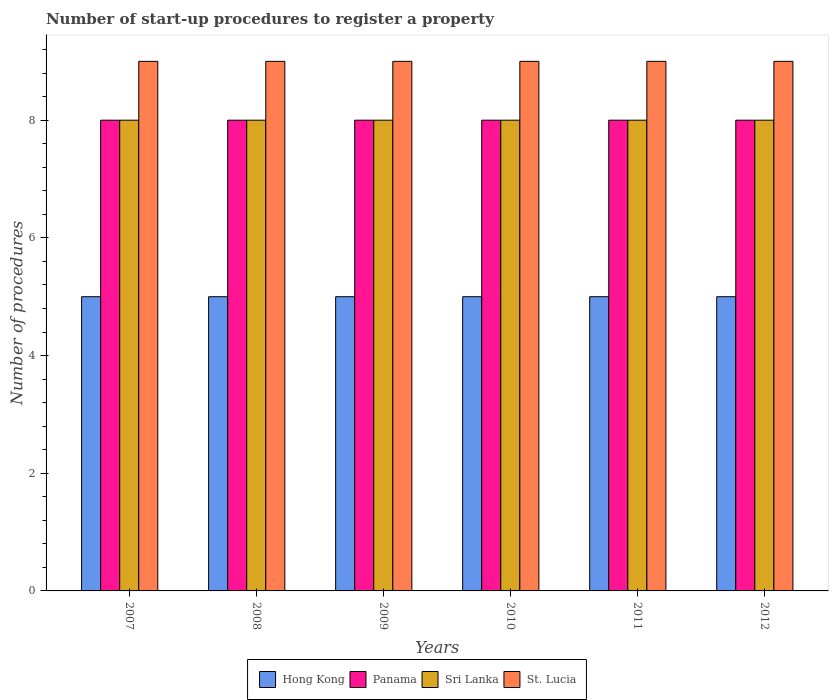How many groups of bars are there?
Your answer should be very brief. 6. Are the number of bars per tick equal to the number of legend labels?
Offer a terse response. Yes. Are the number of bars on each tick of the X-axis equal?
Your answer should be very brief. Yes. How many bars are there on the 2nd tick from the right?
Give a very brief answer. 4. What is the label of the 4th group of bars from the left?
Ensure brevity in your answer.  2010. What is the number of procedures required to register a property in Hong Kong in 2010?
Your response must be concise. 5. Across all years, what is the maximum number of procedures required to register a property in Panama?
Your answer should be compact. 8. Across all years, what is the minimum number of procedures required to register a property in Panama?
Give a very brief answer. 8. In which year was the number of procedures required to register a property in Sri Lanka minimum?
Your answer should be very brief. 2007. What is the total number of procedures required to register a property in Panama in the graph?
Provide a short and direct response. 48. What is the difference between the number of procedures required to register a property in Hong Kong in 2009 and that in 2011?
Your answer should be compact. 0. What is the difference between the number of procedures required to register a property in Hong Kong in 2007 and the number of procedures required to register a property in Sri Lanka in 2012?
Give a very brief answer. -3. What is the average number of procedures required to register a property in Panama per year?
Make the answer very short. 8. In the year 2010, what is the difference between the number of procedures required to register a property in Sri Lanka and number of procedures required to register a property in Hong Kong?
Ensure brevity in your answer.  3. What is the ratio of the number of procedures required to register a property in Sri Lanka in 2008 to that in 2012?
Ensure brevity in your answer.  1. Is the number of procedures required to register a property in Panama in 2007 less than that in 2009?
Your answer should be very brief. No. Is the difference between the number of procedures required to register a property in Sri Lanka in 2008 and 2011 greater than the difference between the number of procedures required to register a property in Hong Kong in 2008 and 2011?
Your answer should be very brief. No. What is the difference between the highest and the lowest number of procedures required to register a property in Sri Lanka?
Provide a short and direct response. 0. Is it the case that in every year, the sum of the number of procedures required to register a property in St. Lucia and number of procedures required to register a property in Hong Kong is greater than the sum of number of procedures required to register a property in Panama and number of procedures required to register a property in Sri Lanka?
Provide a short and direct response. Yes. What does the 2nd bar from the left in 2007 represents?
Offer a very short reply. Panama. What does the 3rd bar from the right in 2007 represents?
Provide a succinct answer. Panama. Are the values on the major ticks of Y-axis written in scientific E-notation?
Keep it short and to the point. No. Does the graph contain any zero values?
Offer a very short reply. No. Does the graph contain grids?
Ensure brevity in your answer.  No. Where does the legend appear in the graph?
Offer a terse response. Bottom center. How many legend labels are there?
Keep it short and to the point. 4. What is the title of the graph?
Your answer should be compact. Number of start-up procedures to register a property. What is the label or title of the Y-axis?
Provide a succinct answer. Number of procedures. What is the Number of procedures in Hong Kong in 2007?
Your answer should be very brief. 5. What is the Number of procedures of Panama in 2007?
Offer a very short reply. 8. What is the Number of procedures in Panama in 2008?
Offer a very short reply. 8. What is the Number of procedures in Sri Lanka in 2008?
Provide a short and direct response. 8. What is the Number of procedures of St. Lucia in 2008?
Give a very brief answer. 9. What is the Number of procedures in Hong Kong in 2009?
Your answer should be very brief. 5. What is the Number of procedures of Sri Lanka in 2009?
Your answer should be compact. 8. What is the Number of procedures in Hong Kong in 2010?
Keep it short and to the point. 5. What is the Number of procedures of St. Lucia in 2010?
Offer a terse response. 9. What is the Number of procedures of Panama in 2011?
Provide a short and direct response. 8. What is the Number of procedures in Sri Lanka in 2012?
Your answer should be very brief. 8. What is the Number of procedures of St. Lucia in 2012?
Make the answer very short. 9. Across all years, what is the maximum Number of procedures of St. Lucia?
Make the answer very short. 9. Across all years, what is the minimum Number of procedures of Hong Kong?
Offer a terse response. 5. Across all years, what is the minimum Number of procedures of Panama?
Keep it short and to the point. 8. Across all years, what is the minimum Number of procedures in St. Lucia?
Your answer should be very brief. 9. What is the total Number of procedures of Panama in the graph?
Provide a succinct answer. 48. What is the total Number of procedures of Sri Lanka in the graph?
Provide a succinct answer. 48. What is the total Number of procedures of St. Lucia in the graph?
Offer a very short reply. 54. What is the difference between the Number of procedures in Panama in 2007 and that in 2008?
Offer a terse response. 0. What is the difference between the Number of procedures of Sri Lanka in 2007 and that in 2008?
Provide a succinct answer. 0. What is the difference between the Number of procedures of Hong Kong in 2007 and that in 2010?
Give a very brief answer. 0. What is the difference between the Number of procedures in St. Lucia in 2007 and that in 2010?
Give a very brief answer. 0. What is the difference between the Number of procedures of Panama in 2007 and that in 2012?
Offer a terse response. 0. What is the difference between the Number of procedures in Sri Lanka in 2007 and that in 2012?
Keep it short and to the point. 0. What is the difference between the Number of procedures of St. Lucia in 2007 and that in 2012?
Your answer should be compact. 0. What is the difference between the Number of procedures of Hong Kong in 2008 and that in 2009?
Provide a short and direct response. 0. What is the difference between the Number of procedures of Sri Lanka in 2008 and that in 2009?
Offer a very short reply. 0. What is the difference between the Number of procedures in Hong Kong in 2008 and that in 2010?
Give a very brief answer. 0. What is the difference between the Number of procedures in Sri Lanka in 2008 and that in 2010?
Your response must be concise. 0. What is the difference between the Number of procedures in Hong Kong in 2008 and that in 2011?
Your answer should be very brief. 0. What is the difference between the Number of procedures of Panama in 2008 and that in 2011?
Ensure brevity in your answer.  0. What is the difference between the Number of procedures of Hong Kong in 2008 and that in 2012?
Offer a very short reply. 0. What is the difference between the Number of procedures of Panama in 2008 and that in 2012?
Your response must be concise. 0. What is the difference between the Number of procedures of Sri Lanka in 2008 and that in 2012?
Make the answer very short. 0. What is the difference between the Number of procedures in St. Lucia in 2008 and that in 2012?
Provide a short and direct response. 0. What is the difference between the Number of procedures in Panama in 2009 and that in 2010?
Give a very brief answer. 0. What is the difference between the Number of procedures of Sri Lanka in 2009 and that in 2010?
Make the answer very short. 0. What is the difference between the Number of procedures of St. Lucia in 2009 and that in 2010?
Your answer should be very brief. 0. What is the difference between the Number of procedures in Hong Kong in 2009 and that in 2011?
Ensure brevity in your answer.  0. What is the difference between the Number of procedures in Panama in 2009 and that in 2011?
Give a very brief answer. 0. What is the difference between the Number of procedures in St. Lucia in 2010 and that in 2011?
Your answer should be compact. 0. What is the difference between the Number of procedures in Panama in 2010 and that in 2012?
Your response must be concise. 0. What is the difference between the Number of procedures of Sri Lanka in 2010 and that in 2012?
Make the answer very short. 0. What is the difference between the Number of procedures in Hong Kong in 2011 and that in 2012?
Keep it short and to the point. 0. What is the difference between the Number of procedures in Hong Kong in 2007 and the Number of procedures in St. Lucia in 2008?
Give a very brief answer. -4. What is the difference between the Number of procedures of Sri Lanka in 2007 and the Number of procedures of St. Lucia in 2008?
Your response must be concise. -1. What is the difference between the Number of procedures of Hong Kong in 2007 and the Number of procedures of Sri Lanka in 2009?
Make the answer very short. -3. What is the difference between the Number of procedures in Hong Kong in 2007 and the Number of procedures in St. Lucia in 2009?
Ensure brevity in your answer.  -4. What is the difference between the Number of procedures of Hong Kong in 2007 and the Number of procedures of Sri Lanka in 2010?
Keep it short and to the point. -3. What is the difference between the Number of procedures of Panama in 2007 and the Number of procedures of St. Lucia in 2010?
Provide a short and direct response. -1. What is the difference between the Number of procedures of Hong Kong in 2007 and the Number of procedures of Sri Lanka in 2011?
Give a very brief answer. -3. What is the difference between the Number of procedures of Hong Kong in 2007 and the Number of procedures of St. Lucia in 2011?
Your response must be concise. -4. What is the difference between the Number of procedures in Panama in 2007 and the Number of procedures in St. Lucia in 2011?
Offer a terse response. -1. What is the difference between the Number of procedures of Panama in 2007 and the Number of procedures of St. Lucia in 2012?
Keep it short and to the point. -1. What is the difference between the Number of procedures in Sri Lanka in 2007 and the Number of procedures in St. Lucia in 2012?
Provide a succinct answer. -1. What is the difference between the Number of procedures of Hong Kong in 2008 and the Number of procedures of Panama in 2009?
Your response must be concise. -3. What is the difference between the Number of procedures in Panama in 2008 and the Number of procedures in Sri Lanka in 2009?
Offer a terse response. 0. What is the difference between the Number of procedures of Panama in 2008 and the Number of procedures of St. Lucia in 2009?
Provide a succinct answer. -1. What is the difference between the Number of procedures of Panama in 2008 and the Number of procedures of St. Lucia in 2010?
Your answer should be very brief. -1. What is the difference between the Number of procedures in Sri Lanka in 2008 and the Number of procedures in St. Lucia in 2010?
Provide a succinct answer. -1. What is the difference between the Number of procedures of Panama in 2008 and the Number of procedures of St. Lucia in 2011?
Provide a short and direct response. -1. What is the difference between the Number of procedures in Hong Kong in 2008 and the Number of procedures in Sri Lanka in 2012?
Your answer should be compact. -3. What is the difference between the Number of procedures in Panama in 2008 and the Number of procedures in Sri Lanka in 2012?
Offer a very short reply. 0. What is the difference between the Number of procedures in Panama in 2008 and the Number of procedures in St. Lucia in 2012?
Your answer should be very brief. -1. What is the difference between the Number of procedures of Hong Kong in 2009 and the Number of procedures of Panama in 2010?
Provide a short and direct response. -3. What is the difference between the Number of procedures in Hong Kong in 2009 and the Number of procedures in Sri Lanka in 2010?
Ensure brevity in your answer.  -3. What is the difference between the Number of procedures in Panama in 2009 and the Number of procedures in Sri Lanka in 2010?
Your response must be concise. 0. What is the difference between the Number of procedures of Panama in 2009 and the Number of procedures of St. Lucia in 2010?
Ensure brevity in your answer.  -1. What is the difference between the Number of procedures of Sri Lanka in 2009 and the Number of procedures of St. Lucia in 2010?
Give a very brief answer. -1. What is the difference between the Number of procedures in Hong Kong in 2009 and the Number of procedures in Panama in 2011?
Keep it short and to the point. -3. What is the difference between the Number of procedures in Hong Kong in 2009 and the Number of procedures in St. Lucia in 2011?
Make the answer very short. -4. What is the difference between the Number of procedures of Panama in 2009 and the Number of procedures of St. Lucia in 2011?
Your response must be concise. -1. What is the difference between the Number of procedures in Hong Kong in 2009 and the Number of procedures in St. Lucia in 2012?
Provide a succinct answer. -4. What is the difference between the Number of procedures in Panama in 2009 and the Number of procedures in Sri Lanka in 2012?
Keep it short and to the point. 0. What is the difference between the Number of procedures of Hong Kong in 2010 and the Number of procedures of Panama in 2011?
Make the answer very short. -3. What is the difference between the Number of procedures of Hong Kong in 2010 and the Number of procedures of Sri Lanka in 2011?
Give a very brief answer. -3. What is the difference between the Number of procedures of Panama in 2010 and the Number of procedures of Sri Lanka in 2011?
Give a very brief answer. 0. What is the difference between the Number of procedures of Hong Kong in 2010 and the Number of procedures of Panama in 2012?
Provide a short and direct response. -3. What is the difference between the Number of procedures in Hong Kong in 2010 and the Number of procedures in Sri Lanka in 2012?
Your response must be concise. -3. What is the difference between the Number of procedures of Hong Kong in 2010 and the Number of procedures of St. Lucia in 2012?
Offer a terse response. -4. What is the difference between the Number of procedures of Panama in 2010 and the Number of procedures of St. Lucia in 2012?
Your answer should be very brief. -1. What is the difference between the Number of procedures of Sri Lanka in 2010 and the Number of procedures of St. Lucia in 2012?
Ensure brevity in your answer.  -1. What is the difference between the Number of procedures in Hong Kong in 2011 and the Number of procedures in Panama in 2012?
Ensure brevity in your answer.  -3. What is the difference between the Number of procedures in Hong Kong in 2011 and the Number of procedures in St. Lucia in 2012?
Your response must be concise. -4. What is the difference between the Number of procedures of Panama in 2011 and the Number of procedures of Sri Lanka in 2012?
Make the answer very short. 0. What is the difference between the Number of procedures in Panama in 2011 and the Number of procedures in St. Lucia in 2012?
Your response must be concise. -1. What is the difference between the Number of procedures in Sri Lanka in 2011 and the Number of procedures in St. Lucia in 2012?
Make the answer very short. -1. In the year 2007, what is the difference between the Number of procedures of Hong Kong and Number of procedures of Panama?
Offer a terse response. -3. In the year 2007, what is the difference between the Number of procedures of Hong Kong and Number of procedures of Sri Lanka?
Keep it short and to the point. -3. In the year 2007, what is the difference between the Number of procedures in Hong Kong and Number of procedures in St. Lucia?
Make the answer very short. -4. In the year 2008, what is the difference between the Number of procedures of Hong Kong and Number of procedures of Panama?
Provide a short and direct response. -3. In the year 2008, what is the difference between the Number of procedures of Panama and Number of procedures of Sri Lanka?
Offer a terse response. 0. In the year 2009, what is the difference between the Number of procedures in Hong Kong and Number of procedures in Panama?
Your response must be concise. -3. In the year 2009, what is the difference between the Number of procedures of Panama and Number of procedures of Sri Lanka?
Offer a very short reply. 0. In the year 2009, what is the difference between the Number of procedures of Sri Lanka and Number of procedures of St. Lucia?
Provide a succinct answer. -1. In the year 2010, what is the difference between the Number of procedures of Panama and Number of procedures of Sri Lanka?
Offer a terse response. 0. In the year 2010, what is the difference between the Number of procedures of Sri Lanka and Number of procedures of St. Lucia?
Ensure brevity in your answer.  -1. In the year 2011, what is the difference between the Number of procedures in Hong Kong and Number of procedures in Sri Lanka?
Offer a terse response. -3. In the year 2011, what is the difference between the Number of procedures of Hong Kong and Number of procedures of St. Lucia?
Your response must be concise. -4. In the year 2011, what is the difference between the Number of procedures in Panama and Number of procedures in Sri Lanka?
Ensure brevity in your answer.  0. In the year 2011, what is the difference between the Number of procedures in Panama and Number of procedures in St. Lucia?
Offer a terse response. -1. In the year 2011, what is the difference between the Number of procedures of Sri Lanka and Number of procedures of St. Lucia?
Your answer should be very brief. -1. In the year 2012, what is the difference between the Number of procedures in Hong Kong and Number of procedures in Panama?
Give a very brief answer. -3. What is the ratio of the Number of procedures of Panama in 2007 to that in 2008?
Provide a short and direct response. 1. What is the ratio of the Number of procedures of St. Lucia in 2007 to that in 2008?
Offer a terse response. 1. What is the ratio of the Number of procedures of St. Lucia in 2007 to that in 2009?
Your answer should be compact. 1. What is the ratio of the Number of procedures in Hong Kong in 2007 to that in 2010?
Your answer should be compact. 1. What is the ratio of the Number of procedures of Panama in 2007 to that in 2010?
Your response must be concise. 1. What is the ratio of the Number of procedures in Sri Lanka in 2007 to that in 2010?
Provide a short and direct response. 1. What is the ratio of the Number of procedures in St. Lucia in 2007 to that in 2010?
Your answer should be compact. 1. What is the ratio of the Number of procedures in Panama in 2007 to that in 2012?
Your answer should be compact. 1. What is the ratio of the Number of procedures of St. Lucia in 2008 to that in 2009?
Ensure brevity in your answer.  1. What is the ratio of the Number of procedures in Hong Kong in 2008 to that in 2010?
Make the answer very short. 1. What is the ratio of the Number of procedures in Panama in 2008 to that in 2010?
Provide a short and direct response. 1. What is the ratio of the Number of procedures of St. Lucia in 2008 to that in 2010?
Ensure brevity in your answer.  1. What is the ratio of the Number of procedures of Panama in 2008 to that in 2011?
Make the answer very short. 1. What is the ratio of the Number of procedures in Sri Lanka in 2008 to that in 2011?
Your answer should be compact. 1. What is the ratio of the Number of procedures of St. Lucia in 2008 to that in 2011?
Provide a short and direct response. 1. What is the ratio of the Number of procedures of Hong Kong in 2008 to that in 2012?
Provide a succinct answer. 1. What is the ratio of the Number of procedures of Panama in 2008 to that in 2012?
Provide a succinct answer. 1. What is the ratio of the Number of procedures in St. Lucia in 2008 to that in 2012?
Keep it short and to the point. 1. What is the ratio of the Number of procedures of Panama in 2009 to that in 2010?
Your response must be concise. 1. What is the ratio of the Number of procedures of Sri Lanka in 2009 to that in 2010?
Give a very brief answer. 1. What is the ratio of the Number of procedures of Panama in 2009 to that in 2011?
Make the answer very short. 1. What is the ratio of the Number of procedures of Sri Lanka in 2009 to that in 2011?
Your answer should be compact. 1. What is the ratio of the Number of procedures in Hong Kong in 2009 to that in 2012?
Offer a terse response. 1. What is the ratio of the Number of procedures of St. Lucia in 2009 to that in 2012?
Your answer should be compact. 1. What is the ratio of the Number of procedures of Sri Lanka in 2010 to that in 2011?
Ensure brevity in your answer.  1. What is the ratio of the Number of procedures in Hong Kong in 2010 to that in 2012?
Ensure brevity in your answer.  1. What is the ratio of the Number of procedures in Panama in 2010 to that in 2012?
Your answer should be very brief. 1. What is the ratio of the Number of procedures in Sri Lanka in 2010 to that in 2012?
Provide a short and direct response. 1. What is the ratio of the Number of procedures in St. Lucia in 2010 to that in 2012?
Give a very brief answer. 1. What is the ratio of the Number of procedures in Sri Lanka in 2011 to that in 2012?
Ensure brevity in your answer.  1. What is the difference between the highest and the second highest Number of procedures of Hong Kong?
Your answer should be compact. 0. What is the difference between the highest and the second highest Number of procedures of St. Lucia?
Make the answer very short. 0. What is the difference between the highest and the lowest Number of procedures in Sri Lanka?
Ensure brevity in your answer.  0. What is the difference between the highest and the lowest Number of procedures of St. Lucia?
Keep it short and to the point. 0. 